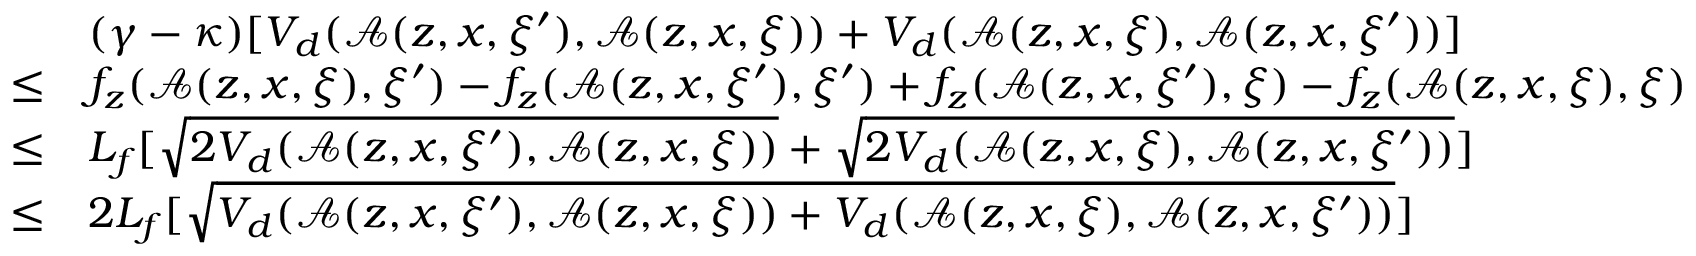<formula> <loc_0><loc_0><loc_500><loc_500>\begin{array} { r l } & { ( \gamma - \kappa ) [ V _ { d } ( \mathcal { A } ( z , x , \xi ^ { \prime } ) , \mathcal { A } ( z , x , \xi ) ) + V _ { d } ( \mathcal { A } ( z , x , \xi ) , \mathcal { A } ( z , x , \xi ^ { \prime } ) ) ] } \\ { \leq } & { f _ { z } ( \mathcal { A } ( z , x , \xi ) , \xi ^ { \prime } ) - f _ { z } ( \mathcal { A } ( z , x , \xi ^ { \prime } ) , \xi ^ { \prime } ) + f _ { z } ( \mathcal { A } ( z , x , \xi ^ { \prime } ) , \xi ) - f _ { z } ( \mathcal { A } ( z , x , \xi ) , \xi ) } \\ { \leq } & { L _ { f } [ \sqrt { 2 V _ { d } ( \mathcal { A } ( z , x , \xi ^ { \prime } ) , \mathcal { A } ( z , x , \xi ) ) } + \sqrt { 2 V _ { d } ( \mathcal { A } ( z , x , \xi ) , \mathcal { A } ( z , x , \xi ^ { \prime } ) ) } ] } \\ { \leq } & { 2 L _ { f } [ \sqrt { V _ { d } ( \mathcal { A } ( z , x , \xi ^ { \prime } ) , \mathcal { A } ( z , x , \xi ) ) + V _ { d } ( \mathcal { A } ( z , x , \xi ) , \mathcal { A } ( z , x , \xi ^ { \prime } ) ) } ] } \end{array}</formula> 